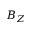Convert formula to latex. <formula><loc_0><loc_0><loc_500><loc_500>B _ { Z }</formula> 